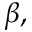Convert formula to latex. <formula><loc_0><loc_0><loc_500><loc_500>\beta ,</formula> 